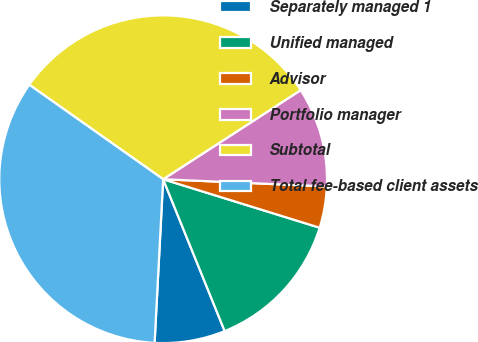Convert chart. <chart><loc_0><loc_0><loc_500><loc_500><pie_chart><fcel>Separately managed 1<fcel>Unified managed<fcel>Advisor<fcel>Portfolio manager<fcel>Subtotal<fcel>Total fee-based client assets<nl><fcel>6.96%<fcel>14.09%<fcel>4.08%<fcel>9.85%<fcel>31.07%<fcel>33.95%<nl></chart> 